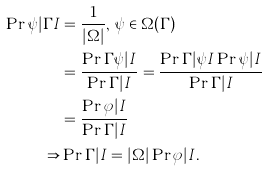<formula> <loc_0><loc_0><loc_500><loc_500>\Pr { \psi | \Gamma I } & = \frac { 1 } { | \Omega | } , \, \psi \in \Omega ( \Gamma ) \\ & = \frac { \Pr { \Gamma \psi | I } } { \Pr { \Gamma | I } } = \frac { \Pr { \Gamma | \psi I } \Pr { \psi | I } } { \Pr { \Gamma | I } } \\ & = \frac { \Pr { \varphi | I } } { \Pr { \Gamma | I } } \\ \Rightarrow & \Pr { \Gamma | I } = | \Omega | \Pr { \varphi | I } .</formula> 